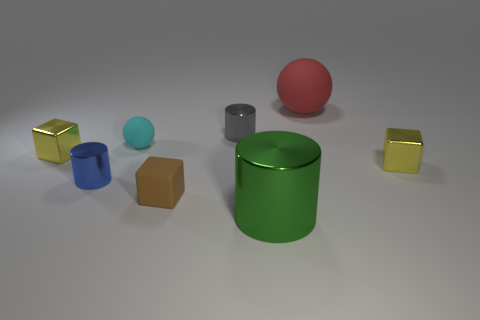How many blocks are tiny yellow things or brown objects?
Your answer should be compact. 3. Are there any other things that are the same size as the cyan thing?
Offer a terse response. Yes. There is a small yellow metal cube behind the small yellow cube that is to the right of the red rubber thing; what number of tiny metallic objects are in front of it?
Provide a short and direct response. 2. Does the large red object have the same shape as the brown thing?
Keep it short and to the point. No. Is the material of the yellow object that is to the right of the big cylinder the same as the small cylinder that is to the left of the small cyan object?
Provide a short and direct response. Yes. How many things are either yellow metallic blocks that are behind the small brown thing or blocks on the right side of the large rubber thing?
Give a very brief answer. 2. Is there any other thing that is the same shape as the gray thing?
Provide a short and direct response. Yes. How many green objects are there?
Offer a very short reply. 1. Are there any red matte cylinders of the same size as the brown block?
Your answer should be very brief. No. Are the red object and the large thing that is to the left of the big red rubber sphere made of the same material?
Your answer should be very brief. No. 